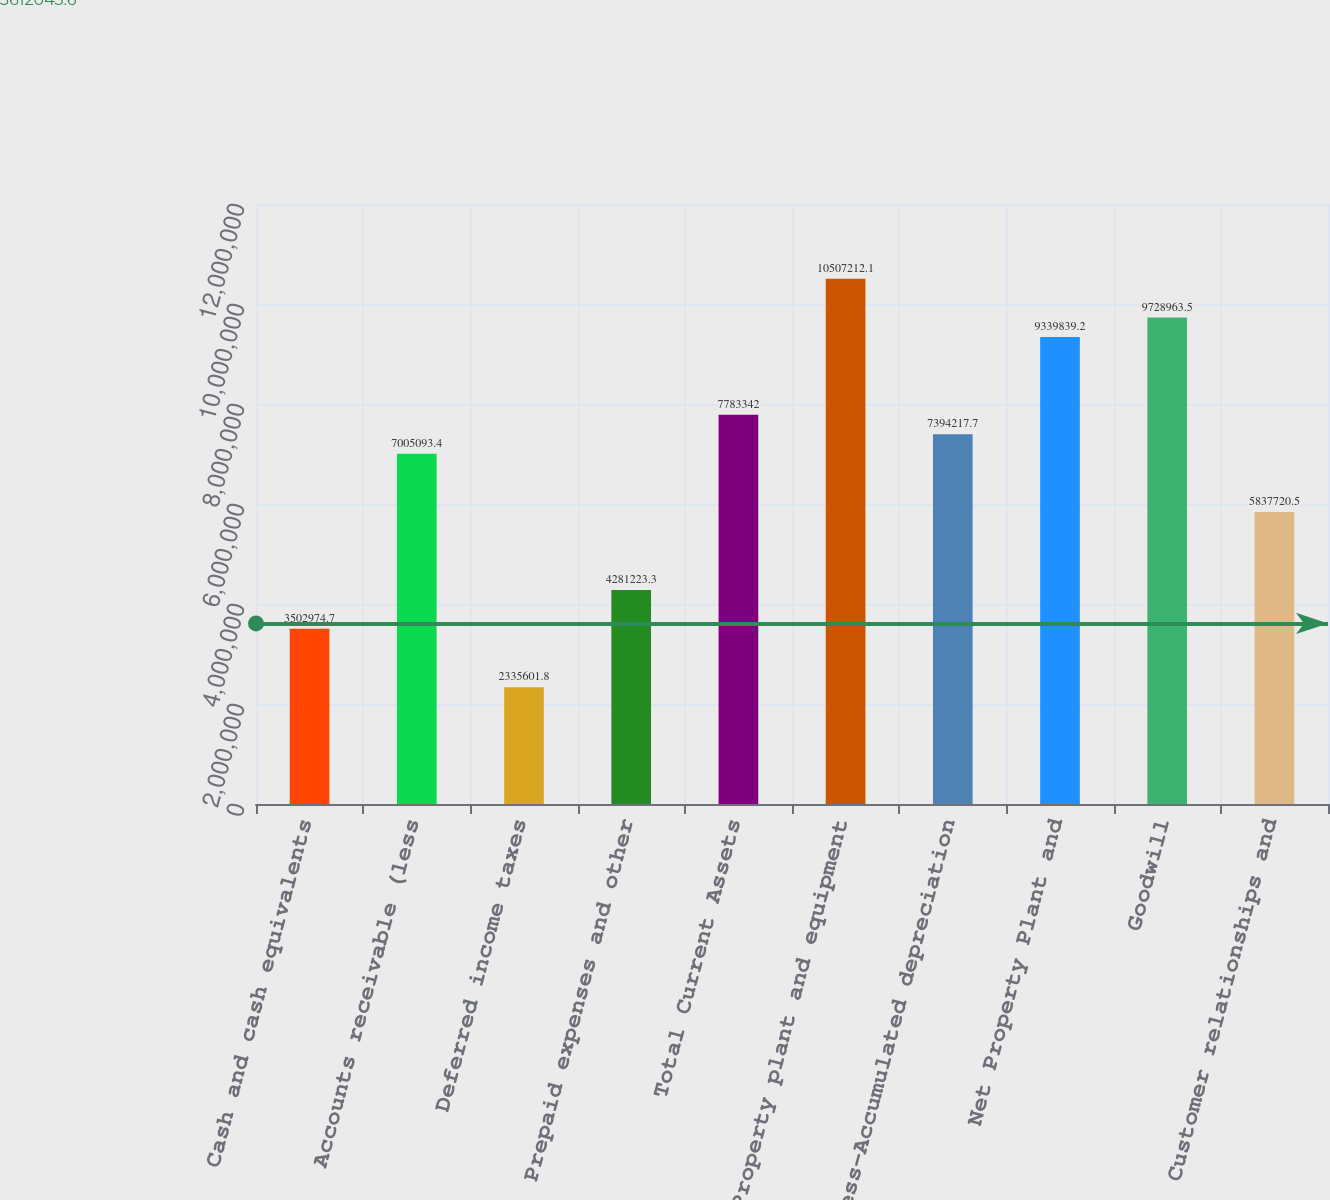<chart> <loc_0><loc_0><loc_500><loc_500><bar_chart><fcel>Cash and cash equivalents<fcel>Accounts receivable (less<fcel>Deferred income taxes<fcel>Prepaid expenses and other<fcel>Total Current Assets<fcel>Property plant and equipment<fcel>Less-Accumulated depreciation<fcel>Net Property Plant and<fcel>Goodwill<fcel>Customer relationships and<nl><fcel>3.50297e+06<fcel>7.00509e+06<fcel>2.3356e+06<fcel>4.28122e+06<fcel>7.78334e+06<fcel>1.05072e+07<fcel>7.39422e+06<fcel>9.33984e+06<fcel>9.72896e+06<fcel>5.83772e+06<nl></chart> 